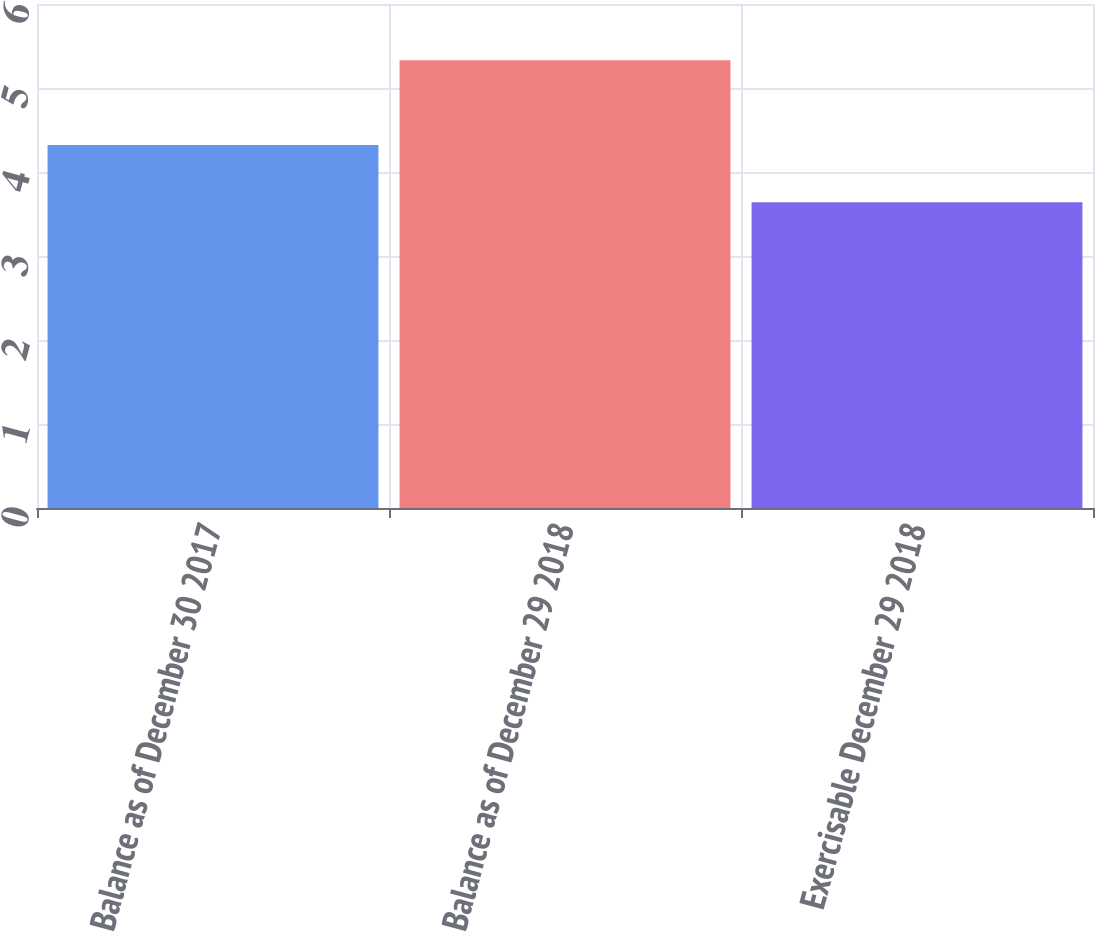<chart> <loc_0><loc_0><loc_500><loc_500><bar_chart><fcel>Balance as of December 30 2017<fcel>Balance as of December 29 2018<fcel>Exercisable December 29 2018<nl><fcel>4.32<fcel>5.33<fcel>3.64<nl></chart> 